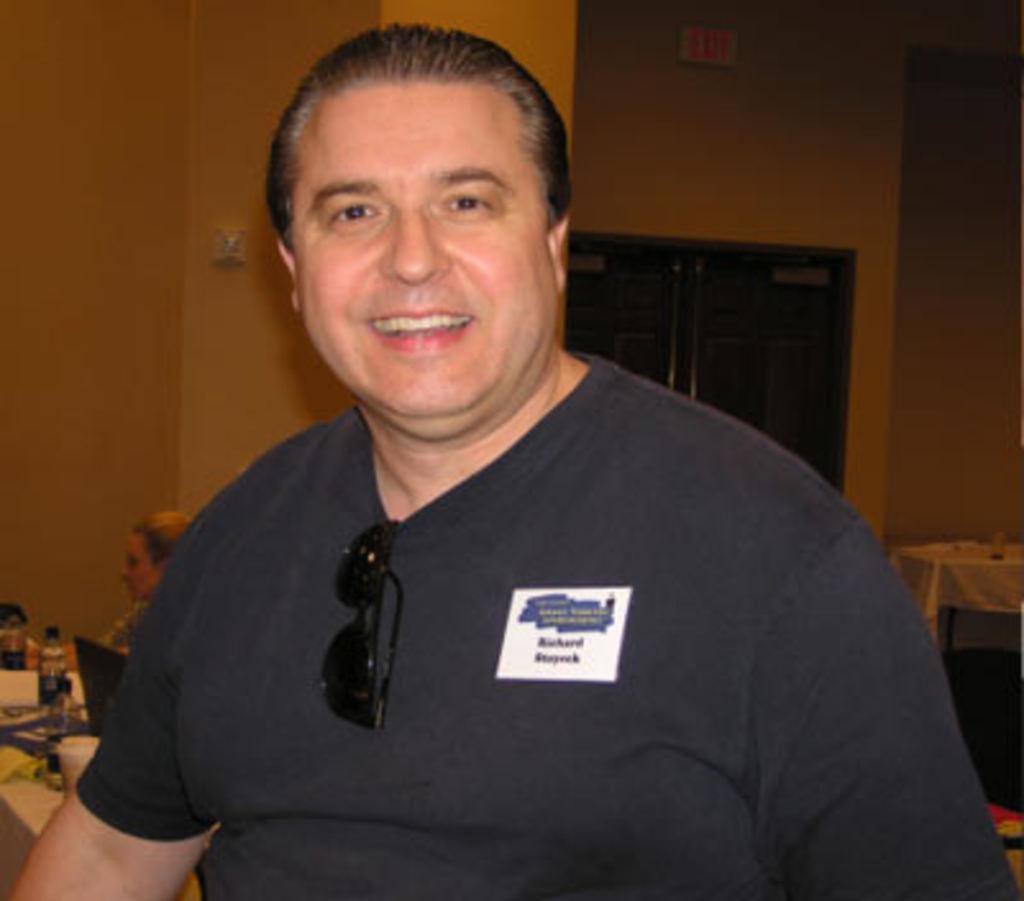Could you give a brief overview of what you see in this image? In the image we can see there is a man standing and there are sunglasses kept on the shirt. Behind there is a woman sitting on the chair and on the table there is laptop, water bottle and coffee cup. 